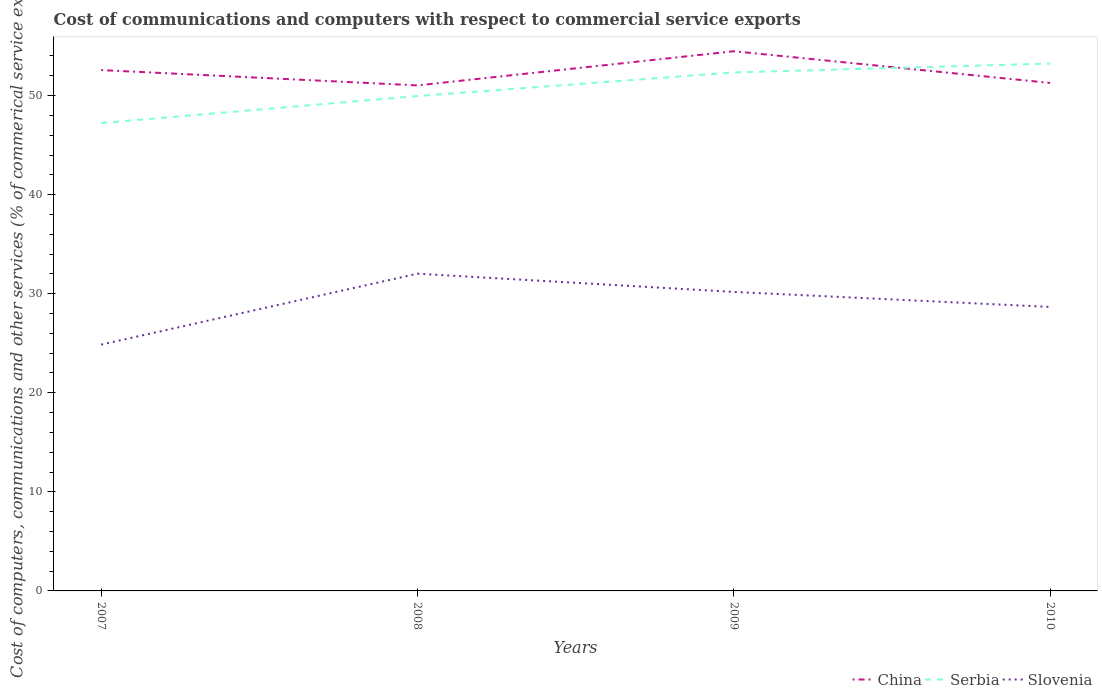Does the line corresponding to Serbia intersect with the line corresponding to China?
Your answer should be compact. Yes. Is the number of lines equal to the number of legend labels?
Provide a short and direct response. Yes. Across all years, what is the maximum cost of communications and computers in China?
Keep it short and to the point. 51.03. In which year was the cost of communications and computers in Serbia maximum?
Make the answer very short. 2007. What is the total cost of communications and computers in China in the graph?
Offer a very short reply. 3.2. What is the difference between the highest and the second highest cost of communications and computers in Slovenia?
Keep it short and to the point. 7.16. What is the difference between the highest and the lowest cost of communications and computers in China?
Your answer should be very brief. 2. How many lines are there?
Keep it short and to the point. 3. Does the graph contain grids?
Provide a succinct answer. No. How many legend labels are there?
Make the answer very short. 3. What is the title of the graph?
Your answer should be very brief. Cost of communications and computers with respect to commercial service exports. What is the label or title of the Y-axis?
Give a very brief answer. Cost of computers, communications and other services (% of commerical service exports). What is the Cost of computers, communications and other services (% of commerical service exports) in China in 2007?
Offer a terse response. 52.58. What is the Cost of computers, communications and other services (% of commerical service exports) of Serbia in 2007?
Offer a very short reply. 47.23. What is the Cost of computers, communications and other services (% of commerical service exports) of Slovenia in 2007?
Offer a terse response. 24.86. What is the Cost of computers, communications and other services (% of commerical service exports) in China in 2008?
Make the answer very short. 51.03. What is the Cost of computers, communications and other services (% of commerical service exports) in Serbia in 2008?
Ensure brevity in your answer.  49.96. What is the Cost of computers, communications and other services (% of commerical service exports) of Slovenia in 2008?
Offer a terse response. 32.02. What is the Cost of computers, communications and other services (% of commerical service exports) of China in 2009?
Offer a terse response. 54.48. What is the Cost of computers, communications and other services (% of commerical service exports) of Serbia in 2009?
Provide a succinct answer. 52.34. What is the Cost of computers, communications and other services (% of commerical service exports) in Slovenia in 2009?
Provide a short and direct response. 30.18. What is the Cost of computers, communications and other services (% of commerical service exports) of China in 2010?
Give a very brief answer. 51.28. What is the Cost of computers, communications and other services (% of commerical service exports) of Serbia in 2010?
Offer a very short reply. 53.23. What is the Cost of computers, communications and other services (% of commerical service exports) in Slovenia in 2010?
Give a very brief answer. 28.67. Across all years, what is the maximum Cost of computers, communications and other services (% of commerical service exports) in China?
Provide a succinct answer. 54.48. Across all years, what is the maximum Cost of computers, communications and other services (% of commerical service exports) of Serbia?
Your response must be concise. 53.23. Across all years, what is the maximum Cost of computers, communications and other services (% of commerical service exports) of Slovenia?
Provide a short and direct response. 32.02. Across all years, what is the minimum Cost of computers, communications and other services (% of commerical service exports) of China?
Provide a succinct answer. 51.03. Across all years, what is the minimum Cost of computers, communications and other services (% of commerical service exports) in Serbia?
Keep it short and to the point. 47.23. Across all years, what is the minimum Cost of computers, communications and other services (% of commerical service exports) in Slovenia?
Offer a very short reply. 24.86. What is the total Cost of computers, communications and other services (% of commerical service exports) of China in the graph?
Keep it short and to the point. 209.37. What is the total Cost of computers, communications and other services (% of commerical service exports) in Serbia in the graph?
Your answer should be very brief. 202.76. What is the total Cost of computers, communications and other services (% of commerical service exports) of Slovenia in the graph?
Your answer should be very brief. 115.74. What is the difference between the Cost of computers, communications and other services (% of commerical service exports) in China in 2007 and that in 2008?
Your response must be concise. 1.55. What is the difference between the Cost of computers, communications and other services (% of commerical service exports) of Serbia in 2007 and that in 2008?
Ensure brevity in your answer.  -2.72. What is the difference between the Cost of computers, communications and other services (% of commerical service exports) in Slovenia in 2007 and that in 2008?
Provide a succinct answer. -7.16. What is the difference between the Cost of computers, communications and other services (% of commerical service exports) in China in 2007 and that in 2009?
Offer a very short reply. -1.9. What is the difference between the Cost of computers, communications and other services (% of commerical service exports) of Serbia in 2007 and that in 2009?
Your response must be concise. -5.11. What is the difference between the Cost of computers, communications and other services (% of commerical service exports) in Slovenia in 2007 and that in 2009?
Offer a terse response. -5.32. What is the difference between the Cost of computers, communications and other services (% of commerical service exports) in China in 2007 and that in 2010?
Make the answer very short. 1.3. What is the difference between the Cost of computers, communications and other services (% of commerical service exports) of Serbia in 2007 and that in 2010?
Ensure brevity in your answer.  -6. What is the difference between the Cost of computers, communications and other services (% of commerical service exports) in Slovenia in 2007 and that in 2010?
Give a very brief answer. -3.81. What is the difference between the Cost of computers, communications and other services (% of commerical service exports) in China in 2008 and that in 2009?
Offer a very short reply. -3.45. What is the difference between the Cost of computers, communications and other services (% of commerical service exports) of Serbia in 2008 and that in 2009?
Your answer should be compact. -2.38. What is the difference between the Cost of computers, communications and other services (% of commerical service exports) of Slovenia in 2008 and that in 2009?
Make the answer very short. 1.84. What is the difference between the Cost of computers, communications and other services (% of commerical service exports) in China in 2008 and that in 2010?
Your answer should be compact. -0.25. What is the difference between the Cost of computers, communications and other services (% of commerical service exports) in Serbia in 2008 and that in 2010?
Offer a terse response. -3.28. What is the difference between the Cost of computers, communications and other services (% of commerical service exports) of Slovenia in 2008 and that in 2010?
Your answer should be compact. 3.35. What is the difference between the Cost of computers, communications and other services (% of commerical service exports) in China in 2009 and that in 2010?
Offer a very short reply. 3.2. What is the difference between the Cost of computers, communications and other services (% of commerical service exports) in Serbia in 2009 and that in 2010?
Provide a short and direct response. -0.9. What is the difference between the Cost of computers, communications and other services (% of commerical service exports) of Slovenia in 2009 and that in 2010?
Make the answer very short. 1.52. What is the difference between the Cost of computers, communications and other services (% of commerical service exports) in China in 2007 and the Cost of computers, communications and other services (% of commerical service exports) in Serbia in 2008?
Your answer should be very brief. 2.62. What is the difference between the Cost of computers, communications and other services (% of commerical service exports) in China in 2007 and the Cost of computers, communications and other services (% of commerical service exports) in Slovenia in 2008?
Give a very brief answer. 20.55. What is the difference between the Cost of computers, communications and other services (% of commerical service exports) in Serbia in 2007 and the Cost of computers, communications and other services (% of commerical service exports) in Slovenia in 2008?
Keep it short and to the point. 15.21. What is the difference between the Cost of computers, communications and other services (% of commerical service exports) of China in 2007 and the Cost of computers, communications and other services (% of commerical service exports) of Serbia in 2009?
Make the answer very short. 0.24. What is the difference between the Cost of computers, communications and other services (% of commerical service exports) of China in 2007 and the Cost of computers, communications and other services (% of commerical service exports) of Slovenia in 2009?
Your answer should be compact. 22.39. What is the difference between the Cost of computers, communications and other services (% of commerical service exports) in Serbia in 2007 and the Cost of computers, communications and other services (% of commerical service exports) in Slovenia in 2009?
Give a very brief answer. 17.05. What is the difference between the Cost of computers, communications and other services (% of commerical service exports) of China in 2007 and the Cost of computers, communications and other services (% of commerical service exports) of Serbia in 2010?
Your answer should be very brief. -0.66. What is the difference between the Cost of computers, communications and other services (% of commerical service exports) in China in 2007 and the Cost of computers, communications and other services (% of commerical service exports) in Slovenia in 2010?
Keep it short and to the point. 23.91. What is the difference between the Cost of computers, communications and other services (% of commerical service exports) in Serbia in 2007 and the Cost of computers, communications and other services (% of commerical service exports) in Slovenia in 2010?
Give a very brief answer. 18.56. What is the difference between the Cost of computers, communications and other services (% of commerical service exports) of China in 2008 and the Cost of computers, communications and other services (% of commerical service exports) of Serbia in 2009?
Offer a terse response. -1.31. What is the difference between the Cost of computers, communications and other services (% of commerical service exports) of China in 2008 and the Cost of computers, communications and other services (% of commerical service exports) of Slovenia in 2009?
Ensure brevity in your answer.  20.85. What is the difference between the Cost of computers, communications and other services (% of commerical service exports) of Serbia in 2008 and the Cost of computers, communications and other services (% of commerical service exports) of Slovenia in 2009?
Offer a terse response. 19.77. What is the difference between the Cost of computers, communications and other services (% of commerical service exports) of China in 2008 and the Cost of computers, communications and other services (% of commerical service exports) of Serbia in 2010?
Offer a very short reply. -2.2. What is the difference between the Cost of computers, communications and other services (% of commerical service exports) of China in 2008 and the Cost of computers, communications and other services (% of commerical service exports) of Slovenia in 2010?
Your answer should be compact. 22.36. What is the difference between the Cost of computers, communications and other services (% of commerical service exports) of Serbia in 2008 and the Cost of computers, communications and other services (% of commerical service exports) of Slovenia in 2010?
Offer a terse response. 21.29. What is the difference between the Cost of computers, communications and other services (% of commerical service exports) of China in 2009 and the Cost of computers, communications and other services (% of commerical service exports) of Serbia in 2010?
Keep it short and to the point. 1.24. What is the difference between the Cost of computers, communications and other services (% of commerical service exports) of China in 2009 and the Cost of computers, communications and other services (% of commerical service exports) of Slovenia in 2010?
Your answer should be compact. 25.81. What is the difference between the Cost of computers, communications and other services (% of commerical service exports) of Serbia in 2009 and the Cost of computers, communications and other services (% of commerical service exports) of Slovenia in 2010?
Your answer should be very brief. 23.67. What is the average Cost of computers, communications and other services (% of commerical service exports) of China per year?
Make the answer very short. 52.34. What is the average Cost of computers, communications and other services (% of commerical service exports) in Serbia per year?
Provide a succinct answer. 50.69. What is the average Cost of computers, communications and other services (% of commerical service exports) in Slovenia per year?
Your response must be concise. 28.93. In the year 2007, what is the difference between the Cost of computers, communications and other services (% of commerical service exports) in China and Cost of computers, communications and other services (% of commerical service exports) in Serbia?
Offer a terse response. 5.35. In the year 2007, what is the difference between the Cost of computers, communications and other services (% of commerical service exports) in China and Cost of computers, communications and other services (% of commerical service exports) in Slovenia?
Keep it short and to the point. 27.72. In the year 2007, what is the difference between the Cost of computers, communications and other services (% of commerical service exports) in Serbia and Cost of computers, communications and other services (% of commerical service exports) in Slovenia?
Offer a terse response. 22.37. In the year 2008, what is the difference between the Cost of computers, communications and other services (% of commerical service exports) of China and Cost of computers, communications and other services (% of commerical service exports) of Serbia?
Make the answer very short. 1.07. In the year 2008, what is the difference between the Cost of computers, communications and other services (% of commerical service exports) in China and Cost of computers, communications and other services (% of commerical service exports) in Slovenia?
Your answer should be very brief. 19.01. In the year 2008, what is the difference between the Cost of computers, communications and other services (% of commerical service exports) of Serbia and Cost of computers, communications and other services (% of commerical service exports) of Slovenia?
Your response must be concise. 17.93. In the year 2009, what is the difference between the Cost of computers, communications and other services (% of commerical service exports) in China and Cost of computers, communications and other services (% of commerical service exports) in Serbia?
Your response must be concise. 2.14. In the year 2009, what is the difference between the Cost of computers, communications and other services (% of commerical service exports) in China and Cost of computers, communications and other services (% of commerical service exports) in Slovenia?
Give a very brief answer. 24.29. In the year 2009, what is the difference between the Cost of computers, communications and other services (% of commerical service exports) of Serbia and Cost of computers, communications and other services (% of commerical service exports) of Slovenia?
Make the answer very short. 22.16. In the year 2010, what is the difference between the Cost of computers, communications and other services (% of commerical service exports) of China and Cost of computers, communications and other services (% of commerical service exports) of Serbia?
Give a very brief answer. -1.95. In the year 2010, what is the difference between the Cost of computers, communications and other services (% of commerical service exports) in China and Cost of computers, communications and other services (% of commerical service exports) in Slovenia?
Your response must be concise. 22.61. In the year 2010, what is the difference between the Cost of computers, communications and other services (% of commerical service exports) of Serbia and Cost of computers, communications and other services (% of commerical service exports) of Slovenia?
Offer a terse response. 24.57. What is the ratio of the Cost of computers, communications and other services (% of commerical service exports) in China in 2007 to that in 2008?
Provide a short and direct response. 1.03. What is the ratio of the Cost of computers, communications and other services (% of commerical service exports) of Serbia in 2007 to that in 2008?
Provide a short and direct response. 0.95. What is the ratio of the Cost of computers, communications and other services (% of commerical service exports) in Slovenia in 2007 to that in 2008?
Offer a very short reply. 0.78. What is the ratio of the Cost of computers, communications and other services (% of commerical service exports) in China in 2007 to that in 2009?
Ensure brevity in your answer.  0.97. What is the ratio of the Cost of computers, communications and other services (% of commerical service exports) of Serbia in 2007 to that in 2009?
Provide a succinct answer. 0.9. What is the ratio of the Cost of computers, communications and other services (% of commerical service exports) of Slovenia in 2007 to that in 2009?
Make the answer very short. 0.82. What is the ratio of the Cost of computers, communications and other services (% of commerical service exports) of China in 2007 to that in 2010?
Your answer should be very brief. 1.03. What is the ratio of the Cost of computers, communications and other services (% of commerical service exports) in Serbia in 2007 to that in 2010?
Give a very brief answer. 0.89. What is the ratio of the Cost of computers, communications and other services (% of commerical service exports) in Slovenia in 2007 to that in 2010?
Ensure brevity in your answer.  0.87. What is the ratio of the Cost of computers, communications and other services (% of commerical service exports) of China in 2008 to that in 2009?
Make the answer very short. 0.94. What is the ratio of the Cost of computers, communications and other services (% of commerical service exports) in Serbia in 2008 to that in 2009?
Give a very brief answer. 0.95. What is the ratio of the Cost of computers, communications and other services (% of commerical service exports) of Slovenia in 2008 to that in 2009?
Provide a short and direct response. 1.06. What is the ratio of the Cost of computers, communications and other services (% of commerical service exports) of China in 2008 to that in 2010?
Ensure brevity in your answer.  1. What is the ratio of the Cost of computers, communications and other services (% of commerical service exports) of Serbia in 2008 to that in 2010?
Provide a short and direct response. 0.94. What is the ratio of the Cost of computers, communications and other services (% of commerical service exports) of Slovenia in 2008 to that in 2010?
Ensure brevity in your answer.  1.12. What is the ratio of the Cost of computers, communications and other services (% of commerical service exports) of China in 2009 to that in 2010?
Keep it short and to the point. 1.06. What is the ratio of the Cost of computers, communications and other services (% of commerical service exports) of Serbia in 2009 to that in 2010?
Your answer should be very brief. 0.98. What is the ratio of the Cost of computers, communications and other services (% of commerical service exports) in Slovenia in 2009 to that in 2010?
Keep it short and to the point. 1.05. What is the difference between the highest and the second highest Cost of computers, communications and other services (% of commerical service exports) in China?
Keep it short and to the point. 1.9. What is the difference between the highest and the second highest Cost of computers, communications and other services (% of commerical service exports) in Serbia?
Your answer should be very brief. 0.9. What is the difference between the highest and the second highest Cost of computers, communications and other services (% of commerical service exports) in Slovenia?
Offer a very short reply. 1.84. What is the difference between the highest and the lowest Cost of computers, communications and other services (% of commerical service exports) in China?
Provide a short and direct response. 3.45. What is the difference between the highest and the lowest Cost of computers, communications and other services (% of commerical service exports) of Serbia?
Provide a short and direct response. 6. What is the difference between the highest and the lowest Cost of computers, communications and other services (% of commerical service exports) in Slovenia?
Ensure brevity in your answer.  7.16. 